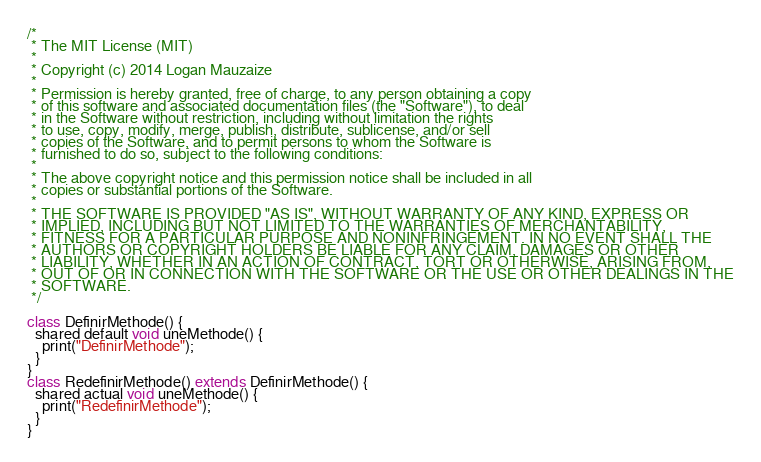Convert code to text. <code><loc_0><loc_0><loc_500><loc_500><_Ceylon_>/*
 * The MIT License (MIT)
 * 
 * Copyright (c) 2014 Logan Mauzaize
 * 
 * Permission is hereby granted, free of charge, to any person obtaining a copy
 * of this software and associated documentation files (the "Software"), to deal
 * in the Software without restriction, including without limitation the rights
 * to use, copy, modify, merge, publish, distribute, sublicense, and/or sell
 * copies of the Software, and to permit persons to whom the Software is
 * furnished to do so, subject to the following conditions:
 *
 * The above copyright notice and this permission notice shall be included in all
 * copies or substantial portions of the Software.
 *
 * THE SOFTWARE IS PROVIDED "AS IS", WITHOUT WARRANTY OF ANY KIND, EXPRESS OR
 * IMPLIED, INCLUDING BUT NOT LIMITED TO THE WARRANTIES OF MERCHANTABILITY,
 * FITNESS FOR A PARTICULAR PURPOSE AND NONINFRINGEMENT. IN NO EVENT SHALL THE
 * AUTHORS OR COPYRIGHT HOLDERS BE LIABLE FOR ANY CLAIM, DAMAGES OR OTHER
 * LIABILITY, WHETHER IN AN ACTION OF CONTRACT, TORT OR OTHERWISE, ARISING FROM,
 * OUT OF OR IN CONNECTION WITH THE SOFTWARE OR THE USE OR OTHER DEALINGS IN THE
 * SOFTWARE.
 */

class DefinirMethode() {
  shared default void uneMethode() {
    print("DefinirMethode");
  }
}
class RedefinirMethode() extends DefinirMethode() {
  shared actual void uneMethode() {
    print("RedefinirMethode");
  }
}
</code> 